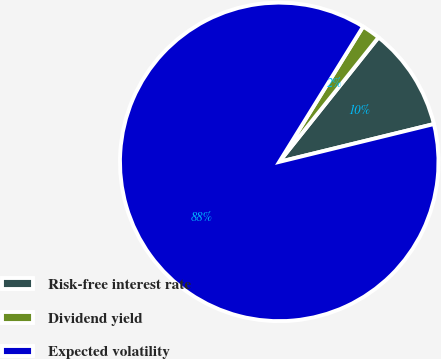Convert chart. <chart><loc_0><loc_0><loc_500><loc_500><pie_chart><fcel>Risk-free interest rate<fcel>Dividend yield<fcel>Expected volatility<nl><fcel>10.47%<fcel>1.88%<fcel>87.65%<nl></chart> 